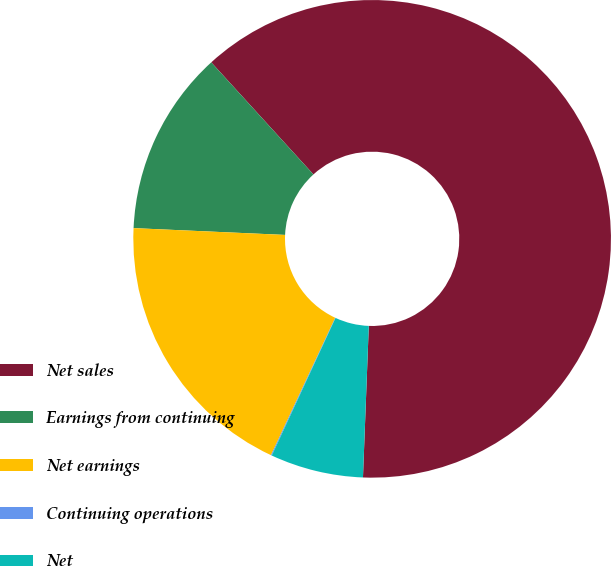Convert chart to OTSL. <chart><loc_0><loc_0><loc_500><loc_500><pie_chart><fcel>Net sales<fcel>Earnings from continuing<fcel>Net earnings<fcel>Continuing operations<fcel>Net<nl><fcel>62.37%<fcel>12.52%<fcel>18.75%<fcel>0.06%<fcel>6.29%<nl></chart> 